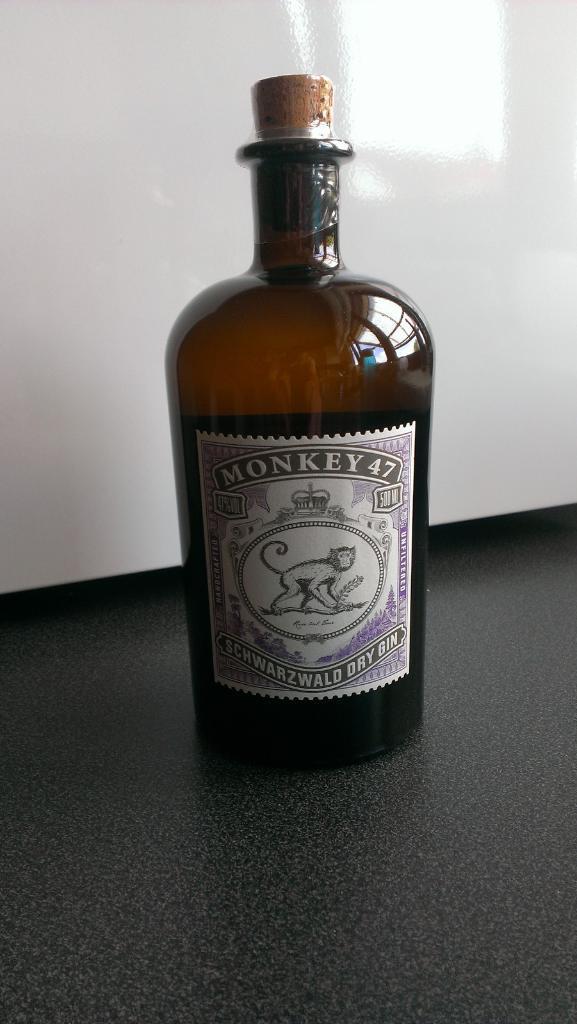Could you give a brief overview of what you see in this image? There is a bottle. There is a sticker on it with some name monkey 47 schwarzwald dry gin. There is a monkey image on the sticker. 